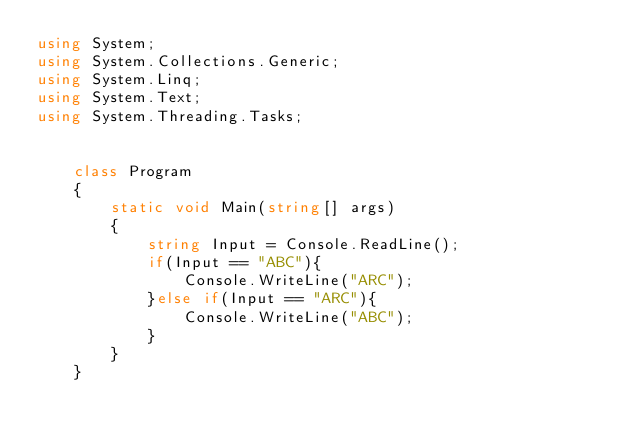Convert code to text. <code><loc_0><loc_0><loc_500><loc_500><_C#_>using System;
using System.Collections.Generic;
using System.Linq;
using System.Text;
using System.Threading.Tasks;


    class Program
    {
        static void Main(string[] args)
        {
            string Input = Console.ReadLine();
            if(Input == "ABC"){
                Console.WriteLine("ARC");
            }else if(Input == "ARC"){
                Console.WriteLine("ABC");
            }
        }
    }
</code> 